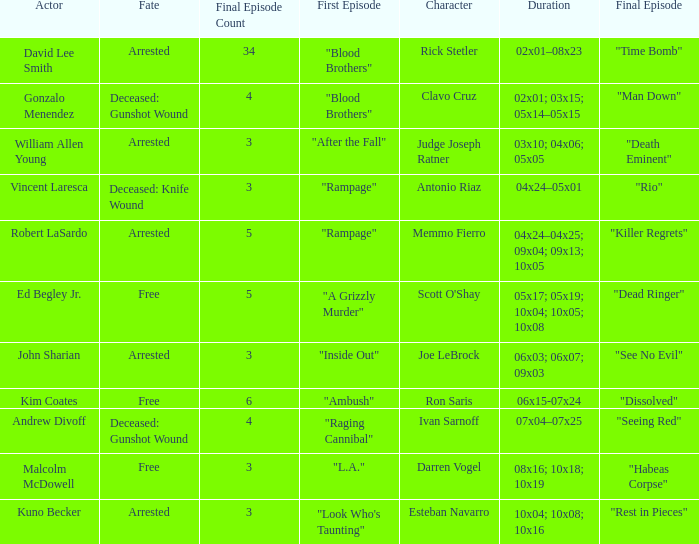What's the actor with character being judge joseph ratner William Allen Young. 